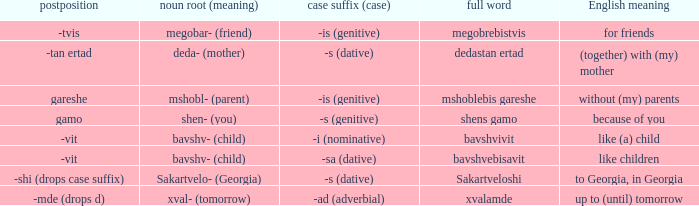What is the Full Word, when Case Suffix (case) is "-sa (dative)"? Bavshvebisavit. 